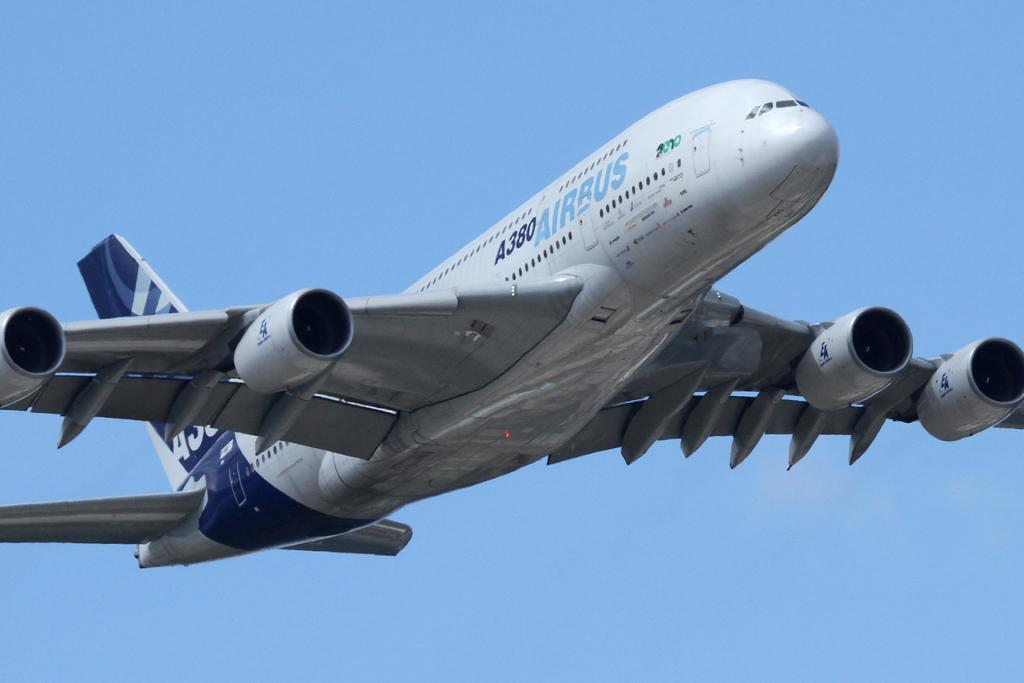<image>
Write a terse but informative summary of the picture. an airbus is flying through the clearblue sky 